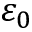Convert formula to latex. <formula><loc_0><loc_0><loc_500><loc_500>\varepsilon _ { 0 }</formula> 